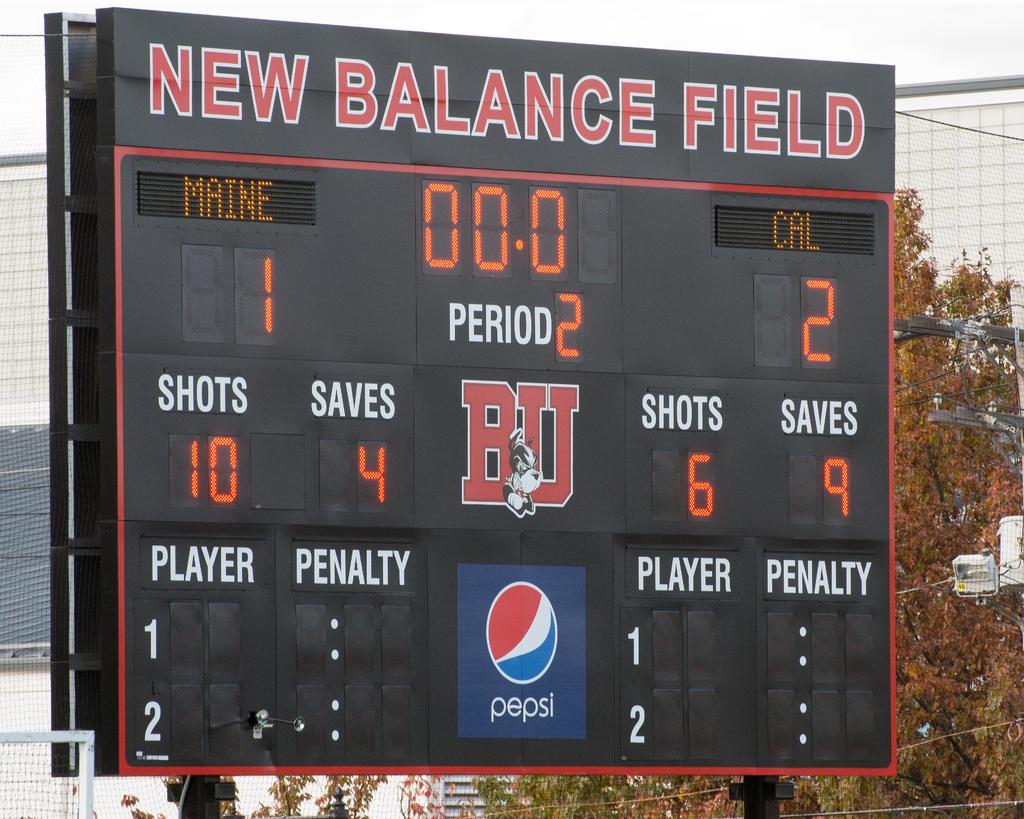Provide a one-sentence caption for the provided image. The scoreboard at New Balance Field that shows period two. 